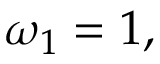<formula> <loc_0><loc_0><loc_500><loc_500>\omega _ { 1 } = 1 ,</formula> 